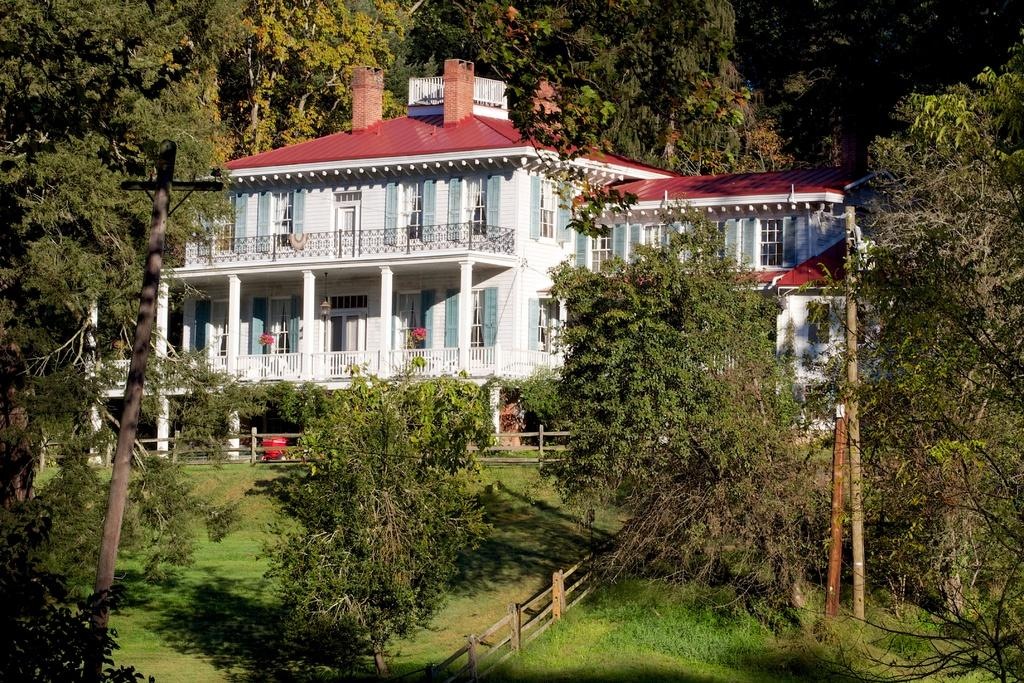What type of structure is present in the image? There is a building in the image. What can be seen in the background of the image? There are trees in the image. What type of vegetation is on the ground in the image? There is grass on the ground in the image. What else can be seen in the image besides the building and trees? There are electrical poles in the image. Can you tell me how many eggs are on the roof of the building in the image? There are no eggs present on the roof of the building in the image. What type of cat can be seen playing with the electrical poles in the image? There is no cat present in the image, and therefore no such activity can be observed. 